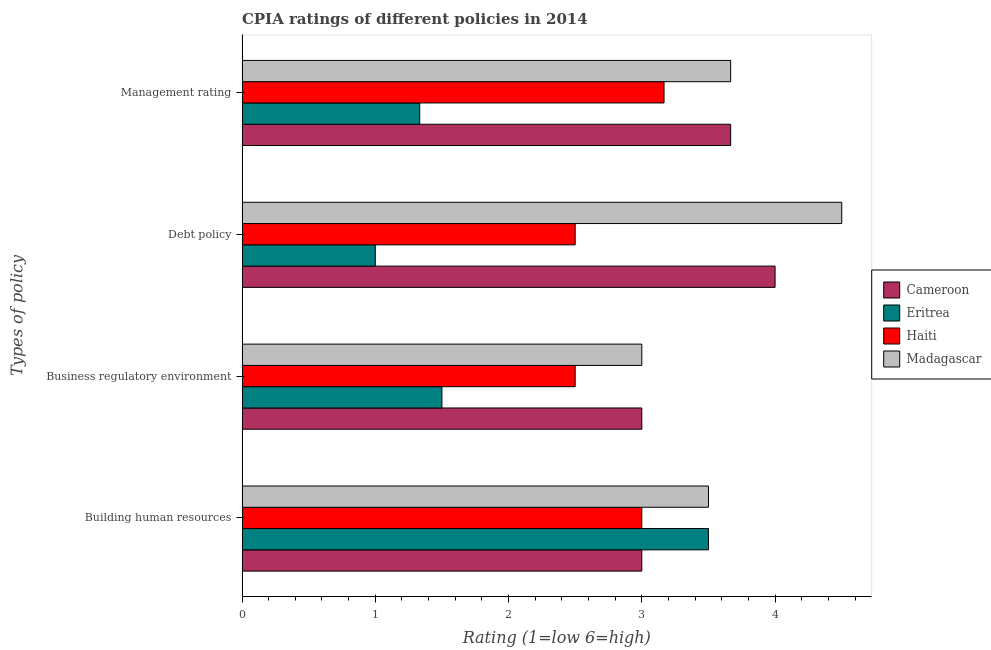Are the number of bars per tick equal to the number of legend labels?
Your answer should be very brief. Yes. What is the label of the 1st group of bars from the top?
Keep it short and to the point. Management rating. What is the cpia rating of debt policy in Cameroon?
Your answer should be compact. 4. Across all countries, what is the maximum cpia rating of debt policy?
Provide a succinct answer. 4.5. Across all countries, what is the minimum cpia rating of business regulatory environment?
Provide a succinct answer. 1.5. In which country was the cpia rating of management maximum?
Keep it short and to the point. Cameroon. In which country was the cpia rating of debt policy minimum?
Make the answer very short. Eritrea. What is the difference between the cpia rating of management in Haiti and the cpia rating of building human resources in Eritrea?
Your response must be concise. -0.33. What is the average cpia rating of building human resources per country?
Your answer should be very brief. 3.25. What is the difference between the cpia rating of business regulatory environment and cpia rating of management in Haiti?
Provide a succinct answer. -0.67. What is the ratio of the cpia rating of business regulatory environment in Madagascar to that in Cameroon?
Offer a terse response. 1. Is the difference between the cpia rating of building human resources in Eritrea and Madagascar greater than the difference between the cpia rating of debt policy in Eritrea and Madagascar?
Offer a terse response. Yes. What is the difference between the highest and the second highest cpia rating of debt policy?
Keep it short and to the point. 0.5. Is it the case that in every country, the sum of the cpia rating of management and cpia rating of business regulatory environment is greater than the sum of cpia rating of building human resources and cpia rating of debt policy?
Keep it short and to the point. No. What does the 1st bar from the top in Business regulatory environment represents?
Keep it short and to the point. Madagascar. What does the 4th bar from the bottom in Management rating represents?
Your response must be concise. Madagascar. How many bars are there?
Give a very brief answer. 16. Are all the bars in the graph horizontal?
Ensure brevity in your answer.  Yes. How many countries are there in the graph?
Your response must be concise. 4. Does the graph contain any zero values?
Give a very brief answer. No. Where does the legend appear in the graph?
Provide a short and direct response. Center right. What is the title of the graph?
Ensure brevity in your answer.  CPIA ratings of different policies in 2014. What is the label or title of the Y-axis?
Your response must be concise. Types of policy. What is the Rating (1=low 6=high) of Eritrea in Building human resources?
Keep it short and to the point. 3.5. What is the Rating (1=low 6=high) in Haiti in Building human resources?
Your answer should be very brief. 3. What is the Rating (1=low 6=high) of Haiti in Business regulatory environment?
Ensure brevity in your answer.  2.5. What is the Rating (1=low 6=high) of Madagascar in Business regulatory environment?
Give a very brief answer. 3. What is the Rating (1=low 6=high) of Cameroon in Debt policy?
Offer a very short reply. 4. What is the Rating (1=low 6=high) in Madagascar in Debt policy?
Ensure brevity in your answer.  4.5. What is the Rating (1=low 6=high) in Cameroon in Management rating?
Make the answer very short. 3.67. What is the Rating (1=low 6=high) in Eritrea in Management rating?
Keep it short and to the point. 1.33. What is the Rating (1=low 6=high) of Haiti in Management rating?
Provide a short and direct response. 3.17. What is the Rating (1=low 6=high) of Madagascar in Management rating?
Provide a short and direct response. 3.67. Across all Types of policy, what is the maximum Rating (1=low 6=high) of Eritrea?
Give a very brief answer. 3.5. Across all Types of policy, what is the maximum Rating (1=low 6=high) in Haiti?
Keep it short and to the point. 3.17. Across all Types of policy, what is the minimum Rating (1=low 6=high) of Cameroon?
Keep it short and to the point. 3. Across all Types of policy, what is the minimum Rating (1=low 6=high) in Eritrea?
Your answer should be very brief. 1. Across all Types of policy, what is the minimum Rating (1=low 6=high) of Haiti?
Provide a succinct answer. 2.5. Across all Types of policy, what is the minimum Rating (1=low 6=high) of Madagascar?
Keep it short and to the point. 3. What is the total Rating (1=low 6=high) in Cameroon in the graph?
Offer a terse response. 13.67. What is the total Rating (1=low 6=high) in Eritrea in the graph?
Offer a very short reply. 7.33. What is the total Rating (1=low 6=high) of Haiti in the graph?
Make the answer very short. 11.17. What is the total Rating (1=low 6=high) in Madagascar in the graph?
Keep it short and to the point. 14.67. What is the difference between the Rating (1=low 6=high) in Cameroon in Building human resources and that in Business regulatory environment?
Your answer should be compact. 0. What is the difference between the Rating (1=low 6=high) in Haiti in Building human resources and that in Business regulatory environment?
Provide a succinct answer. 0.5. What is the difference between the Rating (1=low 6=high) of Madagascar in Building human resources and that in Business regulatory environment?
Offer a terse response. 0.5. What is the difference between the Rating (1=low 6=high) in Eritrea in Building human resources and that in Management rating?
Offer a very short reply. 2.17. What is the difference between the Rating (1=low 6=high) in Cameroon in Business regulatory environment and that in Debt policy?
Your response must be concise. -1. What is the difference between the Rating (1=low 6=high) of Eritrea in Business regulatory environment and that in Debt policy?
Give a very brief answer. 0.5. What is the difference between the Rating (1=low 6=high) of Haiti in Business regulatory environment and that in Debt policy?
Make the answer very short. 0. What is the difference between the Rating (1=low 6=high) of Eritrea in Business regulatory environment and that in Management rating?
Make the answer very short. 0.17. What is the difference between the Rating (1=low 6=high) of Madagascar in Business regulatory environment and that in Management rating?
Provide a succinct answer. -0.67. What is the difference between the Rating (1=low 6=high) of Haiti in Debt policy and that in Management rating?
Offer a terse response. -0.67. What is the difference between the Rating (1=low 6=high) in Madagascar in Debt policy and that in Management rating?
Provide a succinct answer. 0.83. What is the difference between the Rating (1=low 6=high) in Eritrea in Building human resources and the Rating (1=low 6=high) in Madagascar in Business regulatory environment?
Give a very brief answer. 0.5. What is the difference between the Rating (1=low 6=high) in Haiti in Building human resources and the Rating (1=low 6=high) in Madagascar in Business regulatory environment?
Make the answer very short. 0. What is the difference between the Rating (1=low 6=high) of Cameroon in Building human resources and the Rating (1=low 6=high) of Haiti in Debt policy?
Provide a succinct answer. 0.5. What is the difference between the Rating (1=low 6=high) in Eritrea in Building human resources and the Rating (1=low 6=high) in Madagascar in Debt policy?
Your response must be concise. -1. What is the difference between the Rating (1=low 6=high) of Cameroon in Building human resources and the Rating (1=low 6=high) of Eritrea in Management rating?
Make the answer very short. 1.67. What is the difference between the Rating (1=low 6=high) in Cameroon in Building human resources and the Rating (1=low 6=high) in Madagascar in Management rating?
Provide a succinct answer. -0.67. What is the difference between the Rating (1=low 6=high) of Haiti in Building human resources and the Rating (1=low 6=high) of Madagascar in Management rating?
Offer a very short reply. -0.67. What is the difference between the Rating (1=low 6=high) of Cameroon in Business regulatory environment and the Rating (1=low 6=high) of Eritrea in Debt policy?
Your answer should be very brief. 2. What is the difference between the Rating (1=low 6=high) in Cameroon in Business regulatory environment and the Rating (1=low 6=high) in Haiti in Debt policy?
Offer a terse response. 0.5. What is the difference between the Rating (1=low 6=high) in Cameroon in Business regulatory environment and the Rating (1=low 6=high) in Madagascar in Debt policy?
Provide a short and direct response. -1.5. What is the difference between the Rating (1=low 6=high) of Cameroon in Business regulatory environment and the Rating (1=low 6=high) of Eritrea in Management rating?
Offer a terse response. 1.67. What is the difference between the Rating (1=low 6=high) of Cameroon in Business regulatory environment and the Rating (1=low 6=high) of Haiti in Management rating?
Provide a short and direct response. -0.17. What is the difference between the Rating (1=low 6=high) of Eritrea in Business regulatory environment and the Rating (1=low 6=high) of Haiti in Management rating?
Give a very brief answer. -1.67. What is the difference between the Rating (1=low 6=high) in Eritrea in Business regulatory environment and the Rating (1=low 6=high) in Madagascar in Management rating?
Offer a terse response. -2.17. What is the difference between the Rating (1=low 6=high) of Haiti in Business regulatory environment and the Rating (1=low 6=high) of Madagascar in Management rating?
Provide a short and direct response. -1.17. What is the difference between the Rating (1=low 6=high) of Cameroon in Debt policy and the Rating (1=low 6=high) of Eritrea in Management rating?
Your response must be concise. 2.67. What is the difference between the Rating (1=low 6=high) in Eritrea in Debt policy and the Rating (1=low 6=high) in Haiti in Management rating?
Keep it short and to the point. -2.17. What is the difference between the Rating (1=low 6=high) of Eritrea in Debt policy and the Rating (1=low 6=high) of Madagascar in Management rating?
Offer a very short reply. -2.67. What is the difference between the Rating (1=low 6=high) in Haiti in Debt policy and the Rating (1=low 6=high) in Madagascar in Management rating?
Give a very brief answer. -1.17. What is the average Rating (1=low 6=high) in Cameroon per Types of policy?
Offer a terse response. 3.42. What is the average Rating (1=low 6=high) in Eritrea per Types of policy?
Your answer should be compact. 1.83. What is the average Rating (1=low 6=high) of Haiti per Types of policy?
Give a very brief answer. 2.79. What is the average Rating (1=low 6=high) of Madagascar per Types of policy?
Provide a succinct answer. 3.67. What is the difference between the Rating (1=low 6=high) of Cameroon and Rating (1=low 6=high) of Haiti in Building human resources?
Offer a very short reply. 0. What is the difference between the Rating (1=low 6=high) of Cameroon and Rating (1=low 6=high) of Madagascar in Business regulatory environment?
Give a very brief answer. 0. What is the difference between the Rating (1=low 6=high) in Eritrea and Rating (1=low 6=high) in Haiti in Business regulatory environment?
Ensure brevity in your answer.  -1. What is the difference between the Rating (1=low 6=high) in Haiti and Rating (1=low 6=high) in Madagascar in Business regulatory environment?
Your answer should be compact. -0.5. What is the difference between the Rating (1=low 6=high) of Cameroon and Rating (1=low 6=high) of Madagascar in Debt policy?
Offer a very short reply. -0.5. What is the difference between the Rating (1=low 6=high) in Eritrea and Rating (1=low 6=high) in Haiti in Debt policy?
Make the answer very short. -1.5. What is the difference between the Rating (1=low 6=high) in Eritrea and Rating (1=low 6=high) in Madagascar in Debt policy?
Make the answer very short. -3.5. What is the difference between the Rating (1=low 6=high) of Haiti and Rating (1=low 6=high) of Madagascar in Debt policy?
Your answer should be very brief. -2. What is the difference between the Rating (1=low 6=high) of Cameroon and Rating (1=low 6=high) of Eritrea in Management rating?
Ensure brevity in your answer.  2.33. What is the difference between the Rating (1=low 6=high) of Cameroon and Rating (1=low 6=high) of Haiti in Management rating?
Make the answer very short. 0.5. What is the difference between the Rating (1=low 6=high) in Eritrea and Rating (1=low 6=high) in Haiti in Management rating?
Keep it short and to the point. -1.83. What is the difference between the Rating (1=low 6=high) of Eritrea and Rating (1=low 6=high) of Madagascar in Management rating?
Give a very brief answer. -2.33. What is the difference between the Rating (1=low 6=high) in Haiti and Rating (1=low 6=high) in Madagascar in Management rating?
Your answer should be compact. -0.5. What is the ratio of the Rating (1=low 6=high) of Cameroon in Building human resources to that in Business regulatory environment?
Offer a terse response. 1. What is the ratio of the Rating (1=low 6=high) in Eritrea in Building human resources to that in Business regulatory environment?
Ensure brevity in your answer.  2.33. What is the ratio of the Rating (1=low 6=high) of Madagascar in Building human resources to that in Business regulatory environment?
Make the answer very short. 1.17. What is the ratio of the Rating (1=low 6=high) in Eritrea in Building human resources to that in Debt policy?
Your answer should be compact. 3.5. What is the ratio of the Rating (1=low 6=high) of Haiti in Building human resources to that in Debt policy?
Give a very brief answer. 1.2. What is the ratio of the Rating (1=low 6=high) of Cameroon in Building human resources to that in Management rating?
Offer a very short reply. 0.82. What is the ratio of the Rating (1=low 6=high) of Eritrea in Building human resources to that in Management rating?
Offer a terse response. 2.62. What is the ratio of the Rating (1=low 6=high) in Madagascar in Building human resources to that in Management rating?
Keep it short and to the point. 0.95. What is the ratio of the Rating (1=low 6=high) of Cameroon in Business regulatory environment to that in Debt policy?
Your answer should be very brief. 0.75. What is the ratio of the Rating (1=low 6=high) in Eritrea in Business regulatory environment to that in Debt policy?
Offer a very short reply. 1.5. What is the ratio of the Rating (1=low 6=high) of Haiti in Business regulatory environment to that in Debt policy?
Your response must be concise. 1. What is the ratio of the Rating (1=low 6=high) in Madagascar in Business regulatory environment to that in Debt policy?
Your answer should be very brief. 0.67. What is the ratio of the Rating (1=low 6=high) in Cameroon in Business regulatory environment to that in Management rating?
Offer a very short reply. 0.82. What is the ratio of the Rating (1=low 6=high) in Eritrea in Business regulatory environment to that in Management rating?
Offer a terse response. 1.12. What is the ratio of the Rating (1=low 6=high) in Haiti in Business regulatory environment to that in Management rating?
Give a very brief answer. 0.79. What is the ratio of the Rating (1=low 6=high) of Madagascar in Business regulatory environment to that in Management rating?
Your answer should be compact. 0.82. What is the ratio of the Rating (1=low 6=high) of Haiti in Debt policy to that in Management rating?
Your response must be concise. 0.79. What is the ratio of the Rating (1=low 6=high) of Madagascar in Debt policy to that in Management rating?
Provide a short and direct response. 1.23. What is the difference between the highest and the second highest Rating (1=low 6=high) of Cameroon?
Ensure brevity in your answer.  0.33. What is the difference between the highest and the second highest Rating (1=low 6=high) in Eritrea?
Provide a succinct answer. 2. What is the difference between the highest and the second highest Rating (1=low 6=high) in Haiti?
Offer a terse response. 0.17. What is the difference between the highest and the lowest Rating (1=low 6=high) in Eritrea?
Offer a terse response. 2.5. 